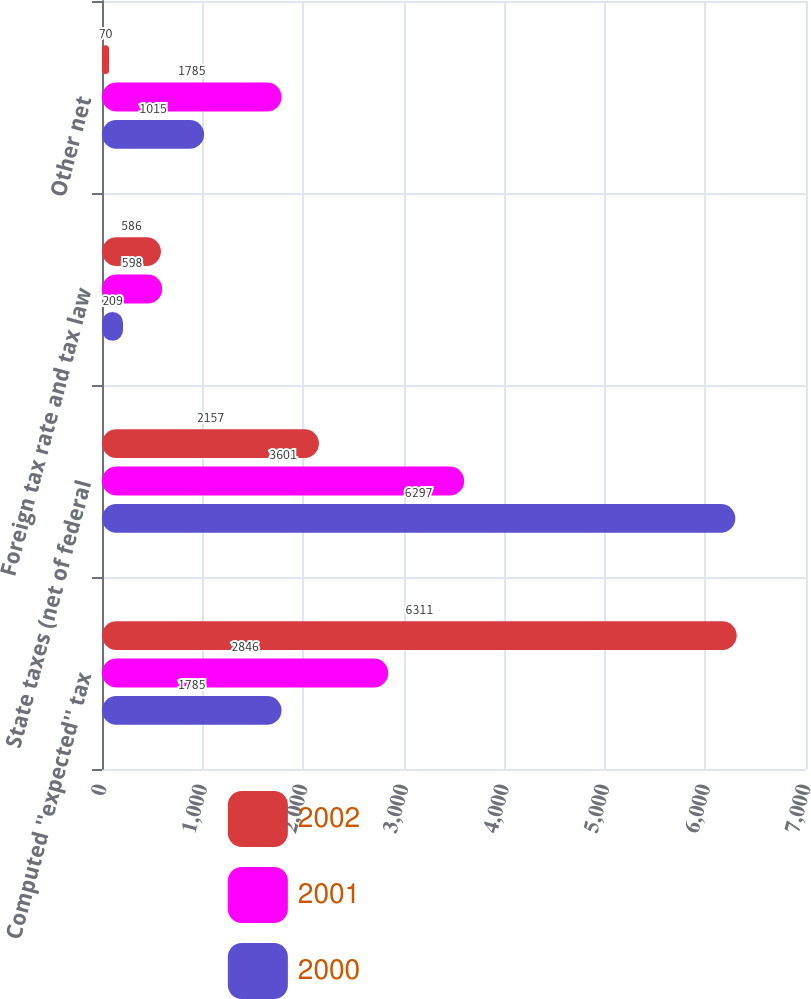<chart> <loc_0><loc_0><loc_500><loc_500><stacked_bar_chart><ecel><fcel>Computed ''expected'' tax<fcel>State taxes (net of federal<fcel>Foreign tax rate and tax law<fcel>Other net<nl><fcel>2002<fcel>6311<fcel>2157<fcel>586<fcel>70<nl><fcel>2001<fcel>2846<fcel>3601<fcel>598<fcel>1785<nl><fcel>2000<fcel>1785<fcel>6297<fcel>209<fcel>1015<nl></chart> 